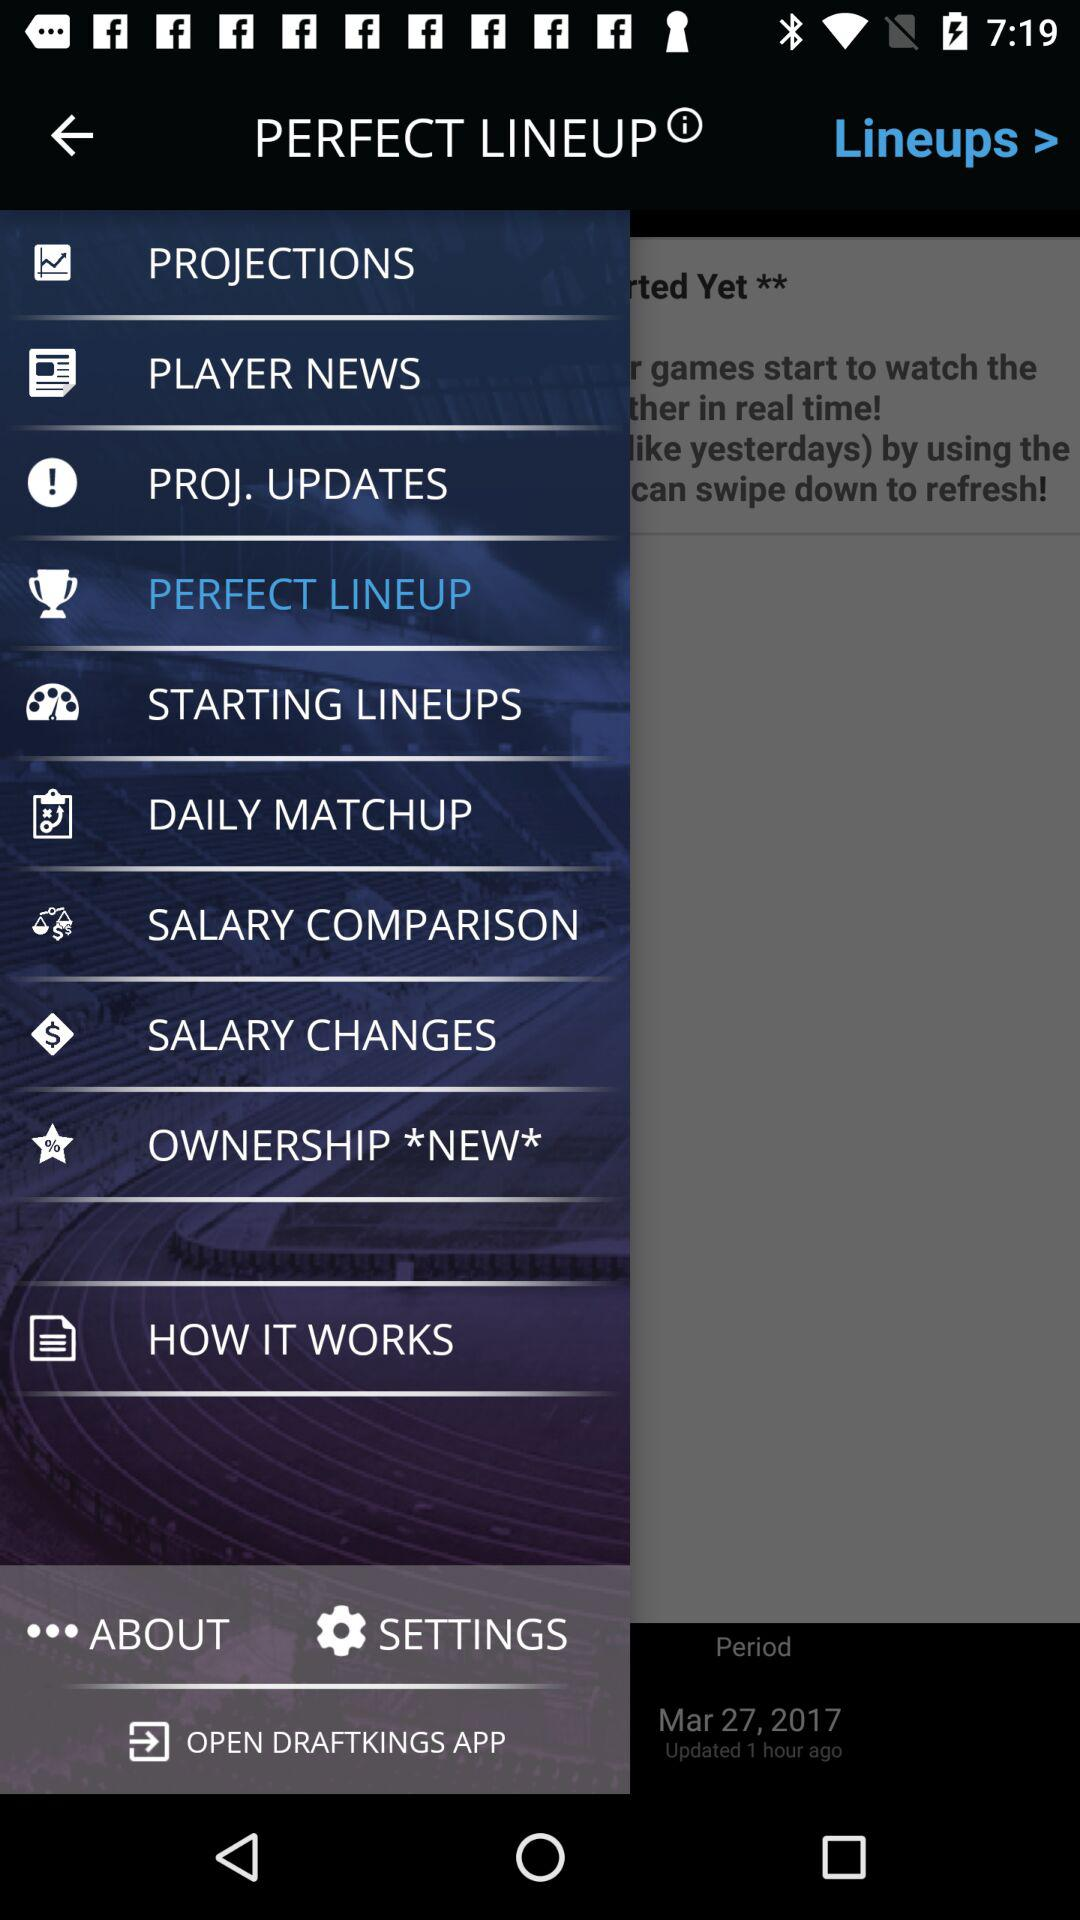What is the application name? The application name is "DRAFTKINGS". 